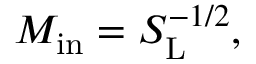Convert formula to latex. <formula><loc_0><loc_0><loc_500><loc_500>M _ { i n } = S _ { L } ^ { - 1 / 2 } ,</formula> 